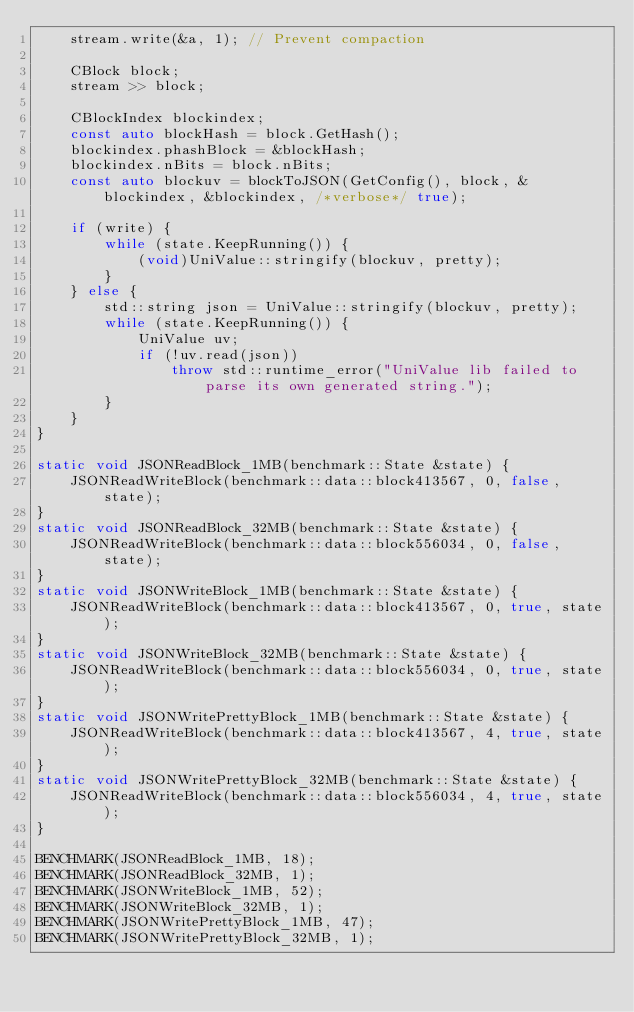<code> <loc_0><loc_0><loc_500><loc_500><_C++_>    stream.write(&a, 1); // Prevent compaction

    CBlock block;
    stream >> block;

    CBlockIndex blockindex;
    const auto blockHash = block.GetHash();
    blockindex.phashBlock = &blockHash;
    blockindex.nBits = block.nBits;
    const auto blockuv = blockToJSON(GetConfig(), block, &blockindex, &blockindex, /*verbose*/ true);

    if (write) {
        while (state.KeepRunning()) {
            (void)UniValue::stringify(blockuv, pretty);
        }
    } else {
        std::string json = UniValue::stringify(blockuv, pretty);
        while (state.KeepRunning()) {
            UniValue uv;
            if (!uv.read(json))
                throw std::runtime_error("UniValue lib failed to parse its own generated string.");
        }
    }
}

static void JSONReadBlock_1MB(benchmark::State &state) {
    JSONReadWriteBlock(benchmark::data::block413567, 0, false, state);
}
static void JSONReadBlock_32MB(benchmark::State &state) {
    JSONReadWriteBlock(benchmark::data::block556034, 0, false, state);
}
static void JSONWriteBlock_1MB(benchmark::State &state) {
    JSONReadWriteBlock(benchmark::data::block413567, 0, true, state);
}
static void JSONWriteBlock_32MB(benchmark::State &state) {
    JSONReadWriteBlock(benchmark::data::block556034, 0, true, state);
}
static void JSONWritePrettyBlock_1MB(benchmark::State &state) {
    JSONReadWriteBlock(benchmark::data::block413567, 4, true, state);
}
static void JSONWritePrettyBlock_32MB(benchmark::State &state) {
    JSONReadWriteBlock(benchmark::data::block556034, 4, true, state);
}

BENCHMARK(JSONReadBlock_1MB, 18);
BENCHMARK(JSONReadBlock_32MB, 1);
BENCHMARK(JSONWriteBlock_1MB, 52);
BENCHMARK(JSONWriteBlock_32MB, 1);
BENCHMARK(JSONWritePrettyBlock_1MB, 47);
BENCHMARK(JSONWritePrettyBlock_32MB, 1);
</code> 